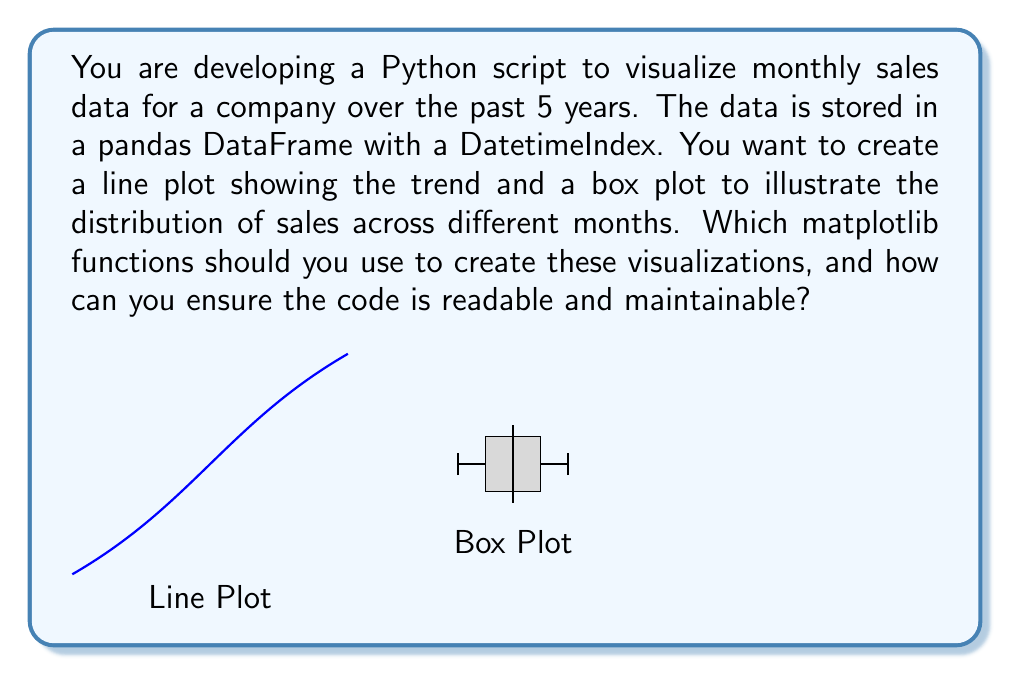Could you help me with this problem? To create readable and maintainable code for visualizing time series data using statistical libraries, we should follow these steps:

1. Import necessary libraries:
   ```python
   import pandas as pd
   import matplotlib.pyplot as plt
   ```

2. Assuming the data is already in a pandas DataFrame called `sales_df` with a DatetimeIndex:

3. For the line plot:
   ```python
   def plot_sales_trend(df):
       plt.figure(figsize=(12, 6))
       plt.plot(df.index, df['sales'], linewidth=2)
       plt.title('Monthly Sales Trend')
       plt.xlabel('Date')
       plt.ylabel('Sales')
       plt.grid(True)
       plt.tight_layout()
       plt.show()
   ```

4. For the box plot:
   ```python
   def plot_monthly_distribution(df):
       plt.figure(figsize=(12, 6))
       df['month'] = df.index.month
       df.boxplot(column='sales', by='month', figsize=(12, 6))
       plt.title('Monthly Sales Distribution')
       plt.xlabel('Month')
       plt.ylabel('Sales')
       plt.suptitle('')  # Remove automatic suptitle
       plt.tight_layout()
       plt.show()
   ```

5. Call the functions:
   ```python
   plot_sales_trend(sales_df)
   plot_monthly_distribution(sales_df)
   ```

This approach uses matplotlib's `plot()` function for the line plot and pandas' `boxplot()` method (which uses matplotlib internally) for the box plot. By encapsulating the plotting logic in separate functions, we improve code readability and maintainability.
Answer: plt.plot() for line plot, df.boxplot() for box plot 